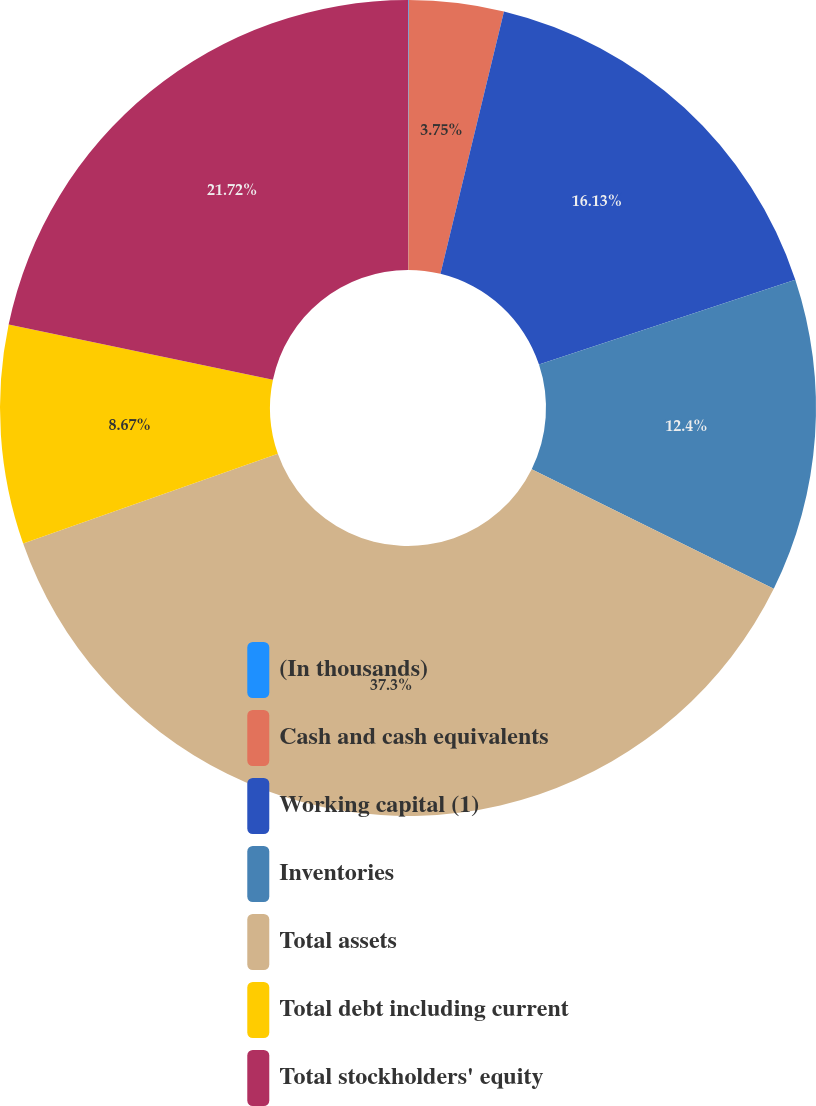Convert chart to OTSL. <chart><loc_0><loc_0><loc_500><loc_500><pie_chart><fcel>(In thousands)<fcel>Cash and cash equivalents<fcel>Working capital (1)<fcel>Inventories<fcel>Total assets<fcel>Total debt including current<fcel>Total stockholders' equity<nl><fcel>0.03%<fcel>3.75%<fcel>16.13%<fcel>12.4%<fcel>37.31%<fcel>8.67%<fcel>21.72%<nl></chart> 